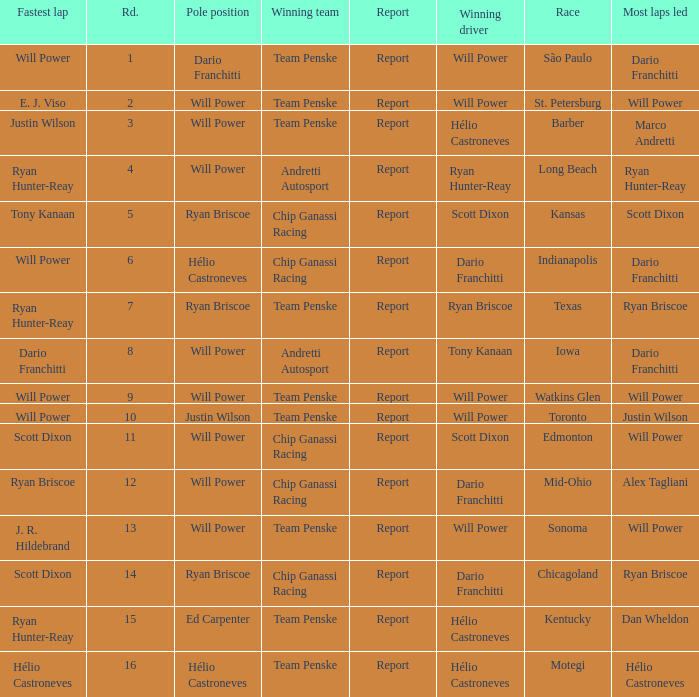What is the report for races where Will Power had both pole position and fastest lap? Report. 